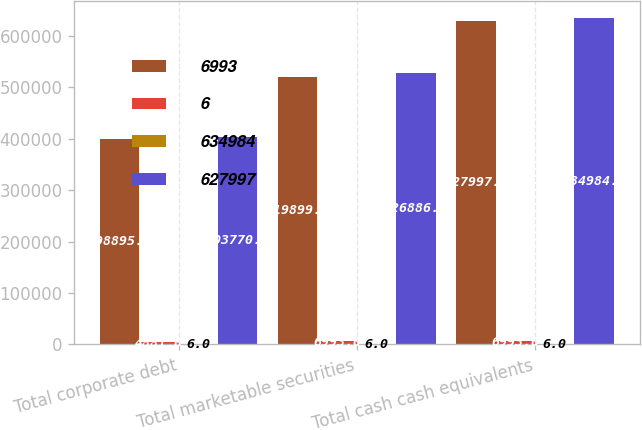Convert chart. <chart><loc_0><loc_0><loc_500><loc_500><stacked_bar_chart><ecel><fcel>Total corporate debt<fcel>Total marketable securities<fcel>Total cash cash equivalents<nl><fcel>6993<fcel>398895<fcel>519899<fcel>627997<nl><fcel>6<fcel>4881<fcel>6993<fcel>6993<nl><fcel>634984<fcel>6<fcel>6<fcel>6<nl><fcel>627997<fcel>403770<fcel>526886<fcel>634984<nl></chart> 